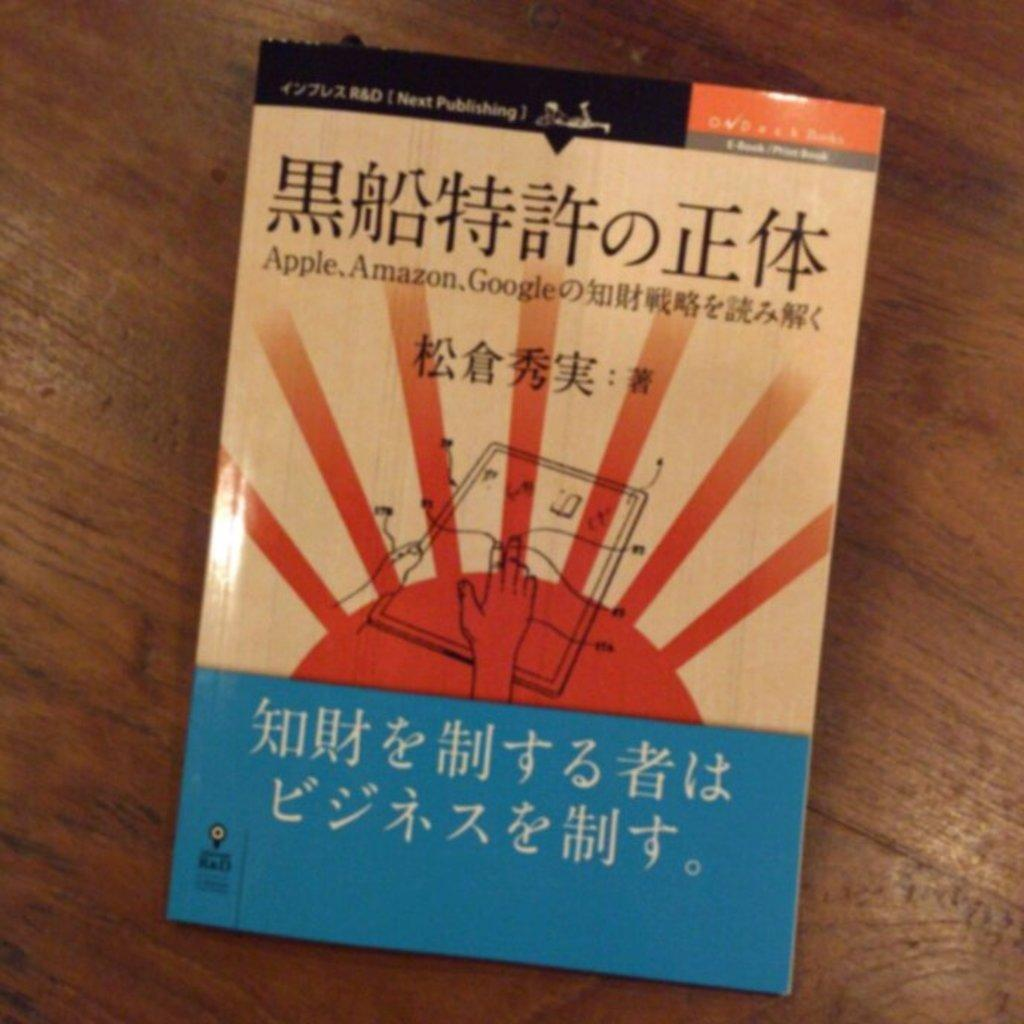<image>
Describe the image concisely. A book jacket contains a large amount of Asian writing and the words Apple, Amazon and Google. 